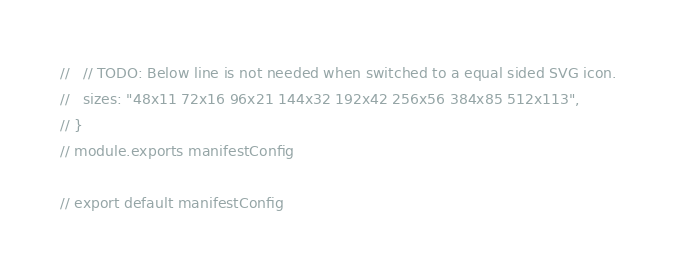<code> <loc_0><loc_0><loc_500><loc_500><_JavaScript_>//   // TODO: Below line is not needed when switched to a equal sided SVG icon.
//   sizes: "48x11 72x16 96x21 144x32 192x42 256x56 384x85 512x113",
// }
// module.exports manifestConfig

// export default manifestConfig
</code> 